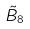<formula> <loc_0><loc_0><loc_500><loc_500>\tilde { B } _ { 8 }</formula> 